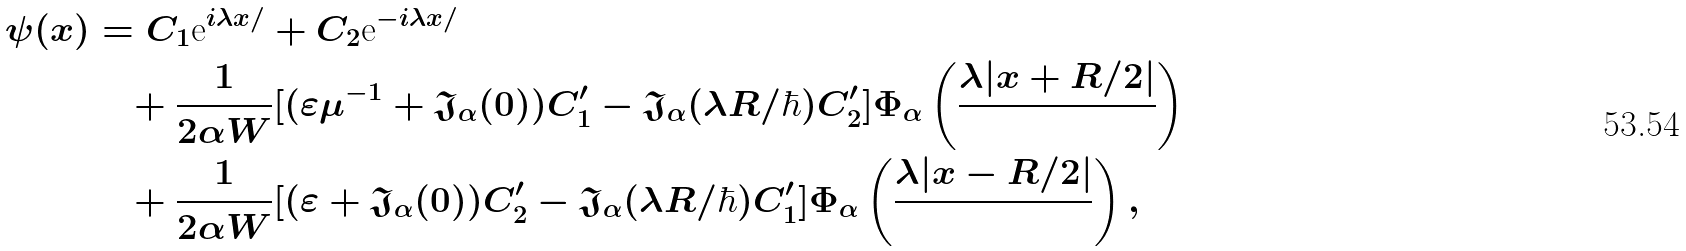<formula> <loc_0><loc_0><loc_500><loc_500>\psi ( x ) & = C _ { 1 } { \mbox e } ^ { i \lambda x / } + C _ { 2 } { \mbox e } ^ { - i \lambda x / } \\ & \quad + \frac { 1 } { 2 \alpha W } [ ( \varepsilon \mu ^ { - 1 } + \mathfrak { J } _ { \alpha } ( 0 ) ) C ^ { \prime } _ { 1 } - \mathfrak { J } _ { \alpha } ( \lambda R / \hbar { ) } C ^ { \prime } _ { 2 } ] \Phi _ { \alpha } \left ( \frac { \lambda | x + R / 2 | } { } \right ) \\ & \quad + \frac { 1 } { 2 \alpha W } [ ( \varepsilon + \mathfrak { J } _ { \alpha } ( 0 ) ) C ^ { \prime } _ { 2 } - \mathfrak { J } _ { \alpha } ( \lambda R / \hbar { ) } C ^ { \prime } _ { 1 } ] \Phi _ { \alpha } \left ( \frac { \lambda | x - R / 2 | } { } \right ) ,</formula> 